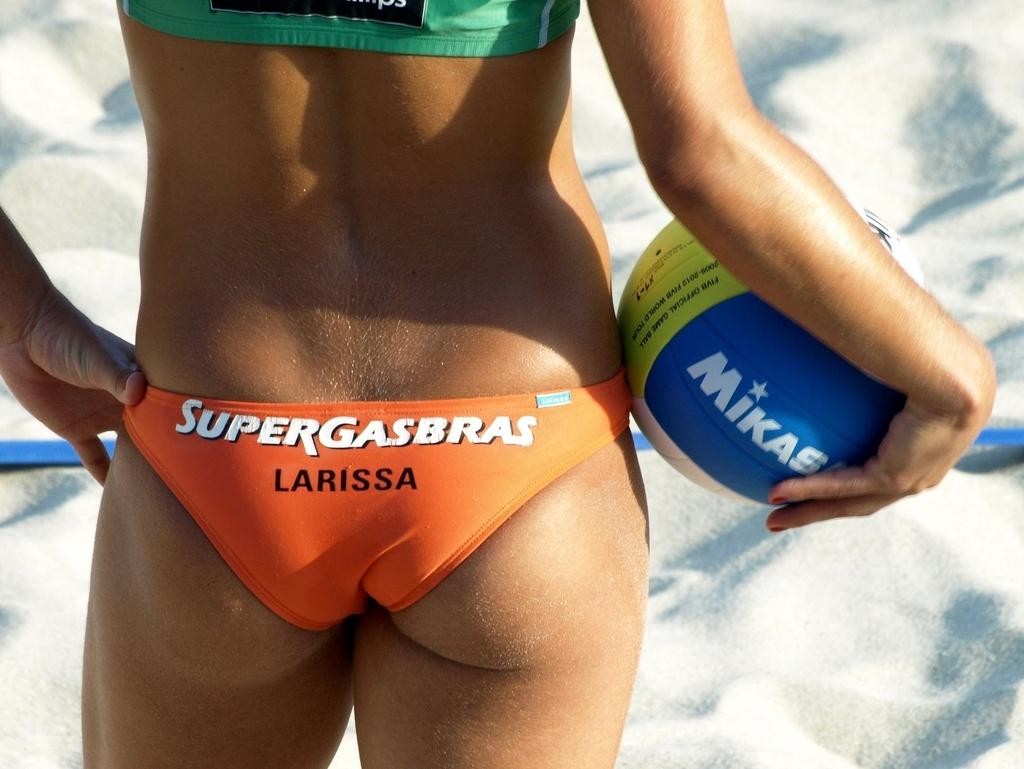Who is the main subject in the image? There is a woman in the image. What is the woman wearing? The woman is wearing a dress. What is the woman holding in her hand? The woman is holding a ball in her hand. Where is the woman standing? The woman is standing on the ground. What type of popcorn can be seen in the woman's hair in the image? There is no popcorn present in the image, and the woman's hair does not have any popcorn in it. 